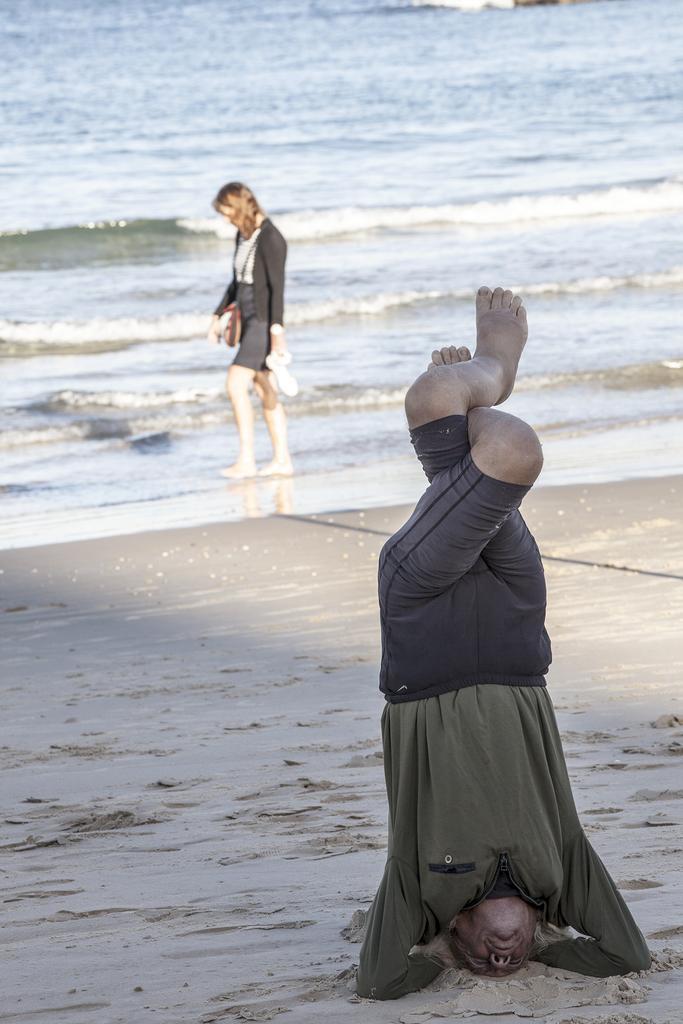How would you summarize this image in a sentence or two? On the right side of the image a man is doing exercise. In the center of the image a lady is walking and carrying bag, shoes. In the background of the image water is there. At the bottom of the image soil is there. 